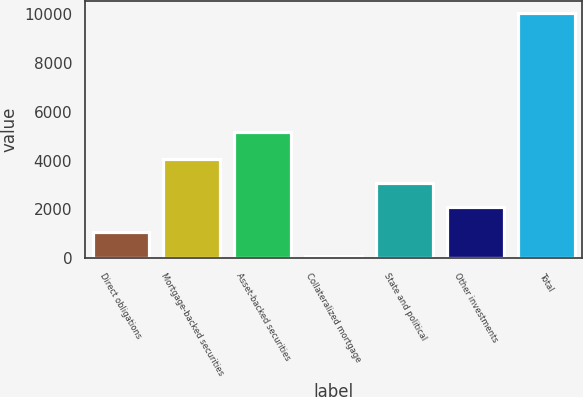<chart> <loc_0><loc_0><loc_500><loc_500><bar_chart><fcel>Direct obligations<fcel>Mortgage-backed securities<fcel>Asset-backed securities<fcel>Collateralized mortgage<fcel>State and political<fcel>Other investments<fcel>Total<nl><fcel>1088.9<fcel>4073.6<fcel>5153<fcel>94<fcel>3078.7<fcel>2083.8<fcel>10043<nl></chart> 